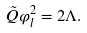Convert formula to latex. <formula><loc_0><loc_0><loc_500><loc_500>\tilde { Q } \varphi ^ { 2 } _ { l } = 2 \Lambda .</formula> 